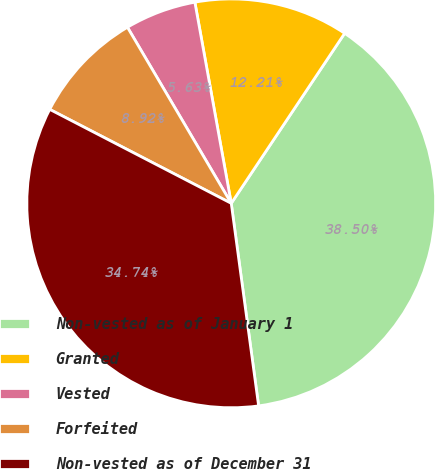Convert chart to OTSL. <chart><loc_0><loc_0><loc_500><loc_500><pie_chart><fcel>Non-vested as of January 1<fcel>Granted<fcel>Vested<fcel>Forfeited<fcel>Non-vested as of December 31<nl><fcel>38.5%<fcel>12.21%<fcel>5.63%<fcel>8.92%<fcel>34.74%<nl></chart> 